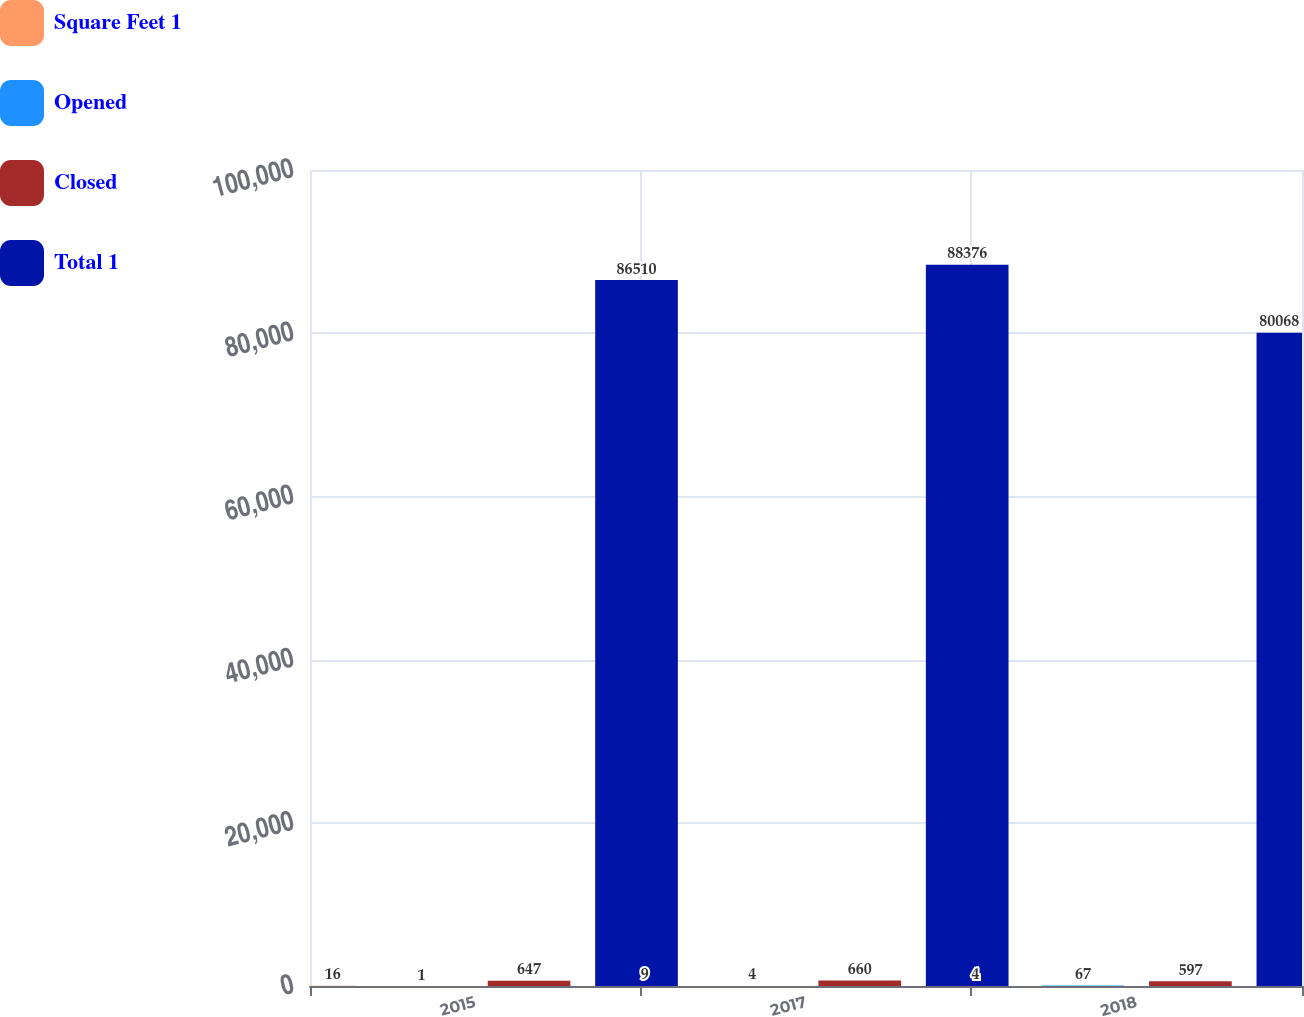<chart> <loc_0><loc_0><loc_500><loc_500><stacked_bar_chart><ecel><fcel>2015<fcel>2017<fcel>2018<nl><fcel>Square Feet 1<fcel>16<fcel>9<fcel>4<nl><fcel>Opened<fcel>1<fcel>4<fcel>67<nl><fcel>Closed<fcel>647<fcel>660<fcel>597<nl><fcel>Total 1<fcel>86510<fcel>88376<fcel>80068<nl></chart> 